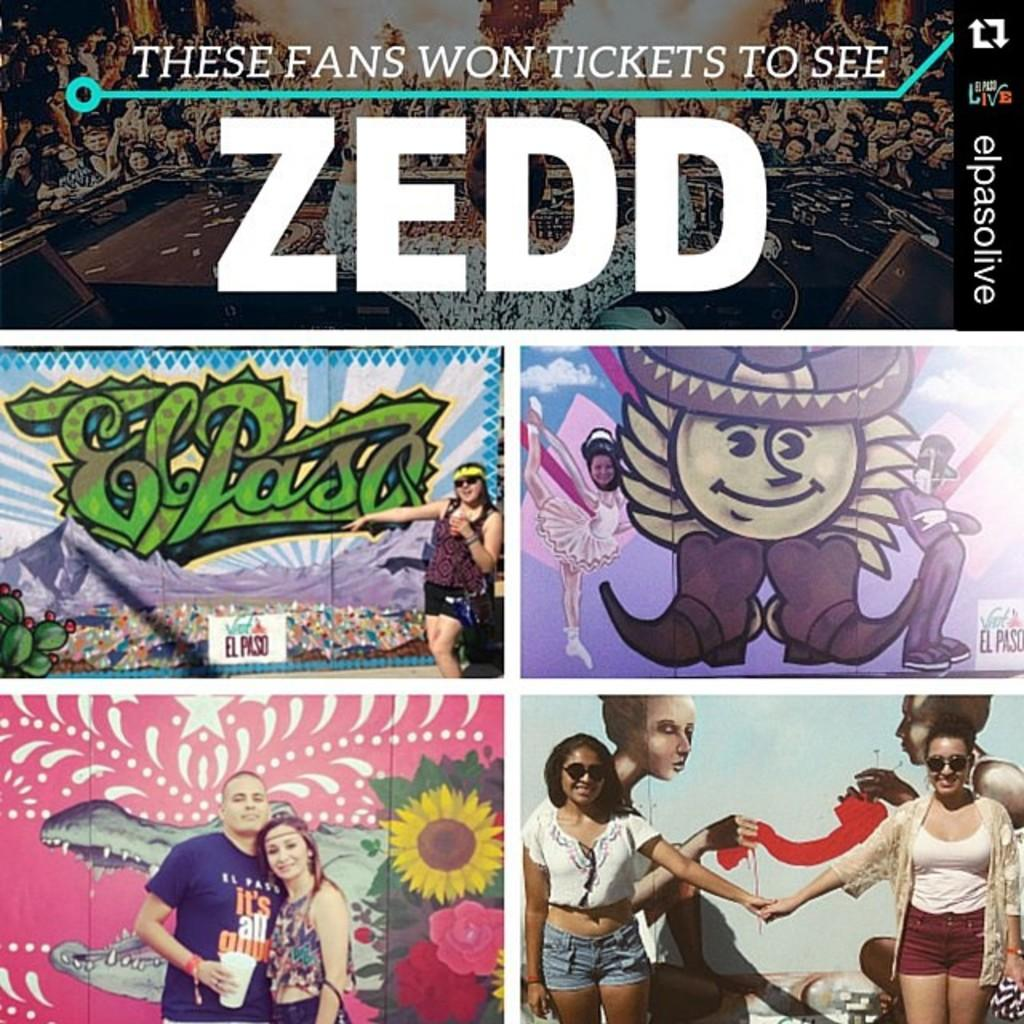<image>
Describe the image concisely. a musical art piece that has the name Zedd on it 